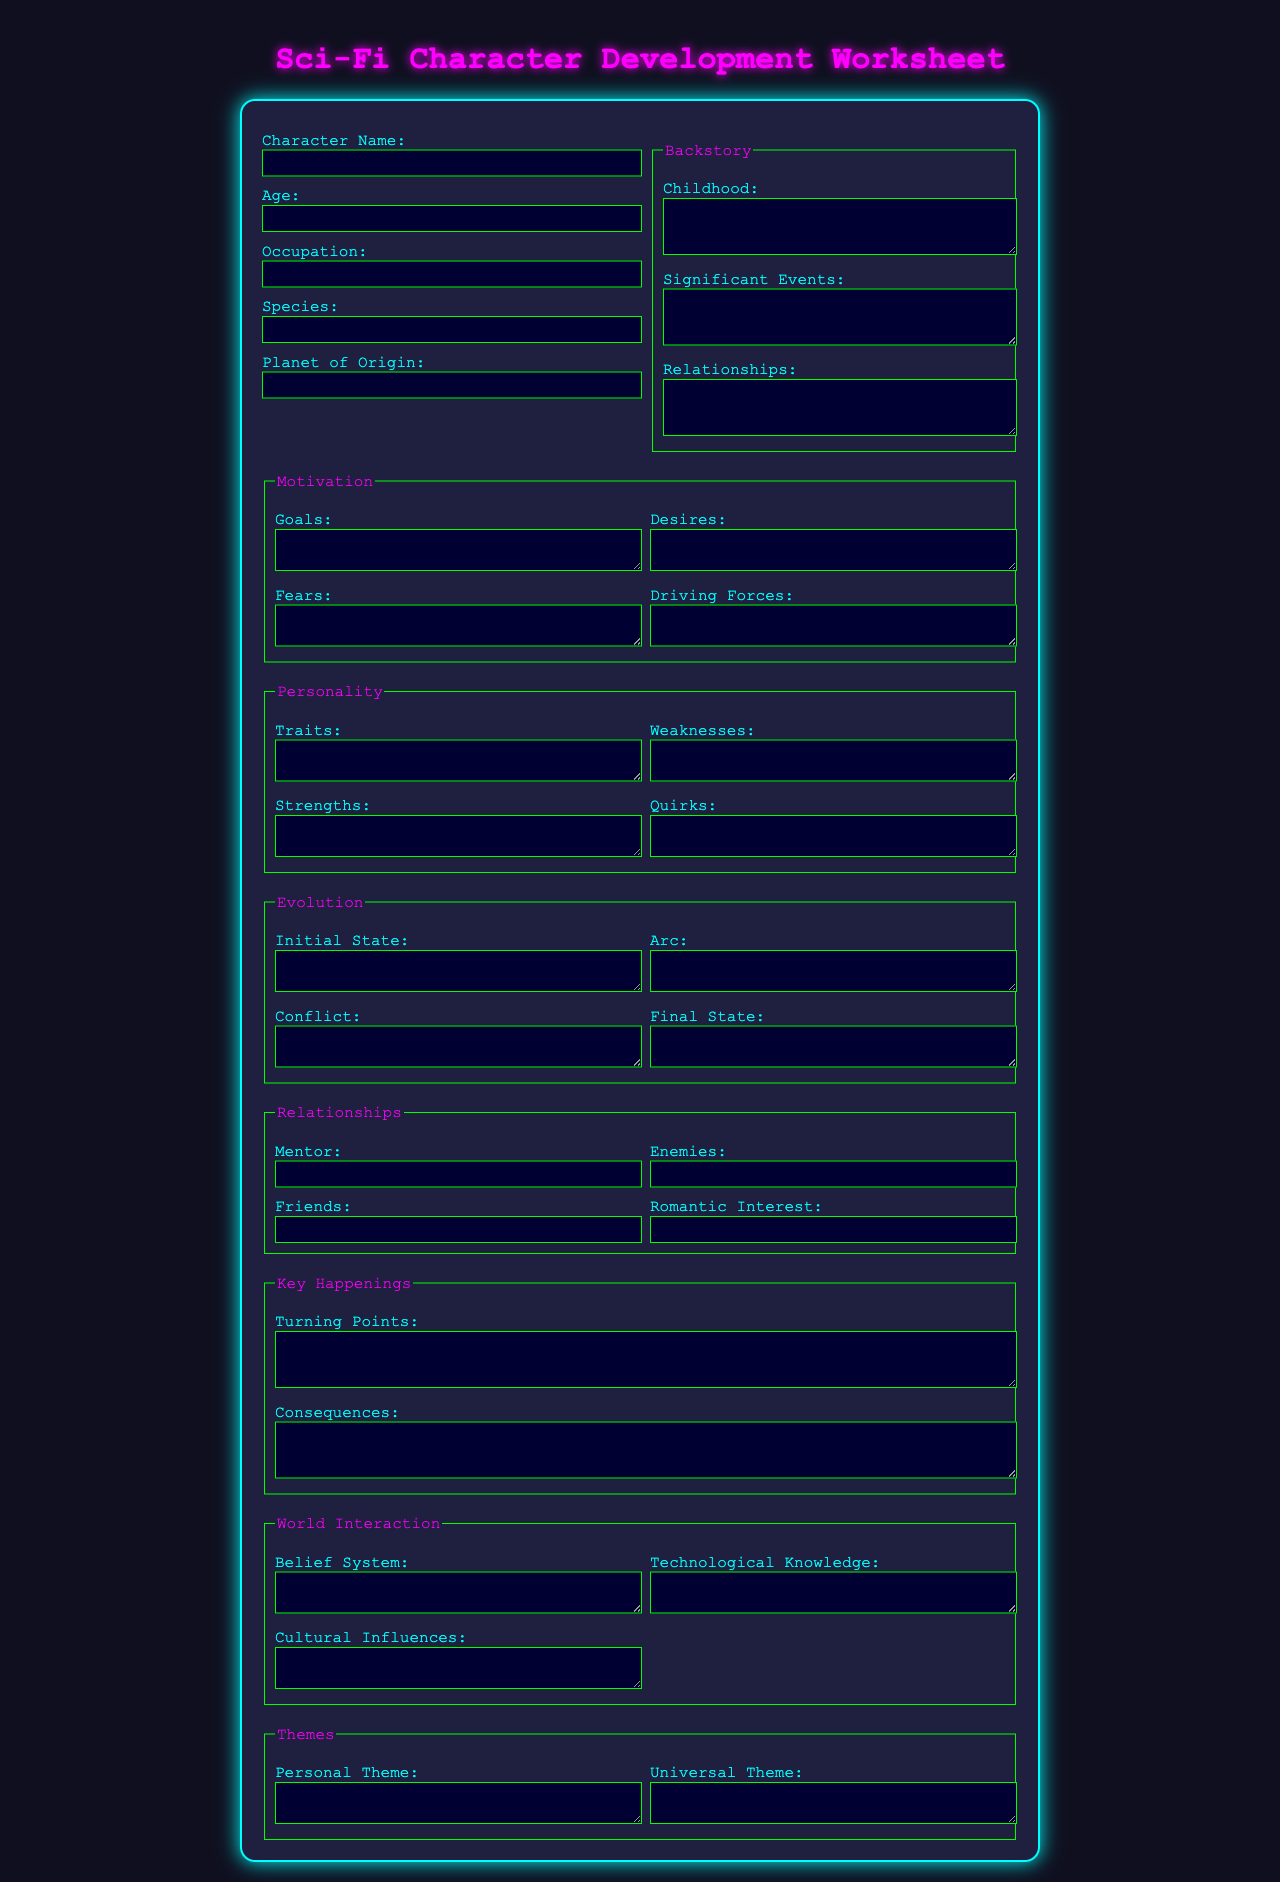What is the title of the document? The title of the document is indicated at the top of the form and is "Sci-Fi Character Development Worksheet."
Answer: Sci-Fi Character Development Worksheet How many fields are in the "Backstory" section? The "Backstory" section contains three fields: Childhood, Significant Events, and Relationships.
Answer: 3 What is the background color of the form? The background color for the entire body of the document is specified as #0f0f1f.
Answer: #0f0f1f What is the last item listed under the "World Interaction" section? The last item listed under the "World Interaction" section is "Technological Knowledge."
Answer: Technological Knowledge What is the purpose of the "Evolution" section? The "Evolution" section is designed to track the character's changes over time through their Initial State, Conflict, Arc, and Final State.
Answer: Track character changes What color is the text for the "Traits" label? The color for the "Traits" label is specified as #00ffff.
Answer: #00ffff What type of element is used for the "Turning Points" query? The "Turning Points" query is represented by a textarea element that allows for multiline input.
Answer: Textarea Which field corresponds to the character's romantic involvement? The field corresponding to the character's romantic involvement is labeled "Romantic Interest."
Answer: Romantic Interest What section comes after "Motivation" in the document? The section that comes after "Motivation" in the document is "Personality."
Answer: Personality 